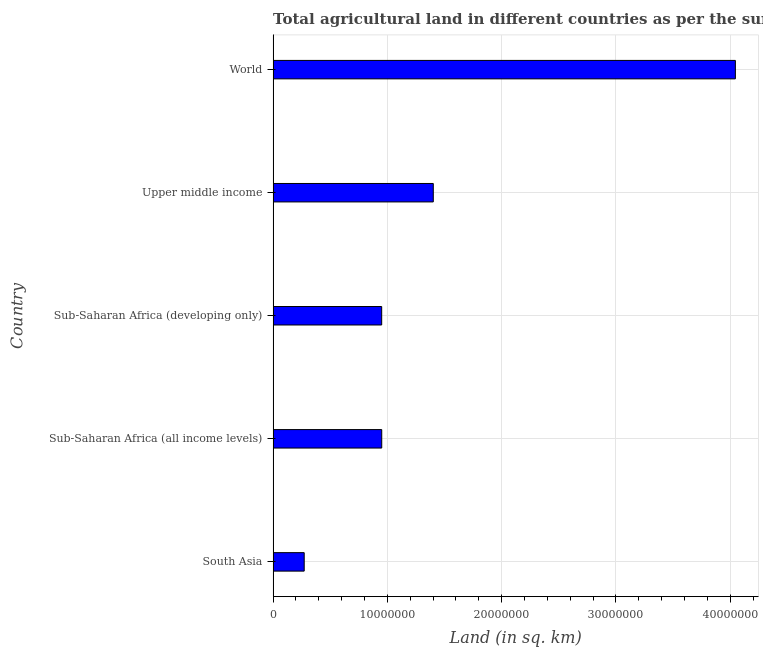Does the graph contain any zero values?
Give a very brief answer. No. Does the graph contain grids?
Ensure brevity in your answer.  Yes. What is the title of the graph?
Your answer should be very brief. Total agricultural land in different countries as per the survey report of the year 1978. What is the label or title of the X-axis?
Keep it short and to the point. Land (in sq. km). What is the agricultural land in South Asia?
Give a very brief answer. 2.72e+06. Across all countries, what is the maximum agricultural land?
Offer a very short reply. 4.04e+07. Across all countries, what is the minimum agricultural land?
Give a very brief answer. 2.72e+06. In which country was the agricultural land minimum?
Offer a very short reply. South Asia. What is the sum of the agricultural land?
Offer a terse response. 7.62e+07. What is the difference between the agricultural land in South Asia and Sub-Saharan Africa (all income levels)?
Keep it short and to the point. -6.78e+06. What is the average agricultural land per country?
Offer a terse response. 1.52e+07. What is the median agricultural land?
Your answer should be very brief. 9.50e+06. In how many countries, is the agricultural land greater than 22000000 sq. km?
Offer a terse response. 1. What is the ratio of the agricultural land in Sub-Saharan Africa (developing only) to that in Upper middle income?
Offer a terse response. 0.68. Is the difference between the agricultural land in Sub-Saharan Africa (all income levels) and Upper middle income greater than the difference between any two countries?
Provide a short and direct response. No. What is the difference between the highest and the second highest agricultural land?
Your answer should be compact. 2.64e+07. Is the sum of the agricultural land in South Asia and World greater than the maximum agricultural land across all countries?
Your answer should be compact. Yes. What is the difference between the highest and the lowest agricultural land?
Offer a terse response. 3.77e+07. In how many countries, is the agricultural land greater than the average agricultural land taken over all countries?
Make the answer very short. 1. How many bars are there?
Your response must be concise. 5. What is the Land (in sq. km) of South Asia?
Your response must be concise. 2.72e+06. What is the Land (in sq. km) in Sub-Saharan Africa (all income levels)?
Offer a very short reply. 9.50e+06. What is the Land (in sq. km) of Sub-Saharan Africa (developing only)?
Provide a short and direct response. 9.50e+06. What is the Land (in sq. km) of Upper middle income?
Offer a terse response. 1.40e+07. What is the Land (in sq. km) in World?
Your answer should be very brief. 4.04e+07. What is the difference between the Land (in sq. km) in South Asia and Sub-Saharan Africa (all income levels)?
Offer a very short reply. -6.78e+06. What is the difference between the Land (in sq. km) in South Asia and Sub-Saharan Africa (developing only)?
Your answer should be very brief. -6.78e+06. What is the difference between the Land (in sq. km) in South Asia and Upper middle income?
Make the answer very short. -1.13e+07. What is the difference between the Land (in sq. km) in South Asia and World?
Keep it short and to the point. -3.77e+07. What is the difference between the Land (in sq. km) in Sub-Saharan Africa (all income levels) and Sub-Saharan Africa (developing only)?
Provide a succinct answer. 3390. What is the difference between the Land (in sq. km) in Sub-Saharan Africa (all income levels) and Upper middle income?
Ensure brevity in your answer.  -4.51e+06. What is the difference between the Land (in sq. km) in Sub-Saharan Africa (all income levels) and World?
Make the answer very short. -3.09e+07. What is the difference between the Land (in sq. km) in Sub-Saharan Africa (developing only) and Upper middle income?
Ensure brevity in your answer.  -4.51e+06. What is the difference between the Land (in sq. km) in Sub-Saharan Africa (developing only) and World?
Make the answer very short. -3.09e+07. What is the difference between the Land (in sq. km) in Upper middle income and World?
Your response must be concise. -2.64e+07. What is the ratio of the Land (in sq. km) in South Asia to that in Sub-Saharan Africa (all income levels)?
Keep it short and to the point. 0.29. What is the ratio of the Land (in sq. km) in South Asia to that in Sub-Saharan Africa (developing only)?
Provide a succinct answer. 0.29. What is the ratio of the Land (in sq. km) in South Asia to that in Upper middle income?
Your answer should be compact. 0.19. What is the ratio of the Land (in sq. km) in South Asia to that in World?
Your answer should be compact. 0.07. What is the ratio of the Land (in sq. km) in Sub-Saharan Africa (all income levels) to that in Sub-Saharan Africa (developing only)?
Provide a short and direct response. 1. What is the ratio of the Land (in sq. km) in Sub-Saharan Africa (all income levels) to that in Upper middle income?
Provide a succinct answer. 0.68. What is the ratio of the Land (in sq. km) in Sub-Saharan Africa (all income levels) to that in World?
Offer a very short reply. 0.23. What is the ratio of the Land (in sq. km) in Sub-Saharan Africa (developing only) to that in Upper middle income?
Offer a terse response. 0.68. What is the ratio of the Land (in sq. km) in Sub-Saharan Africa (developing only) to that in World?
Your answer should be compact. 0.23. What is the ratio of the Land (in sq. km) in Upper middle income to that in World?
Your answer should be very brief. 0.35. 